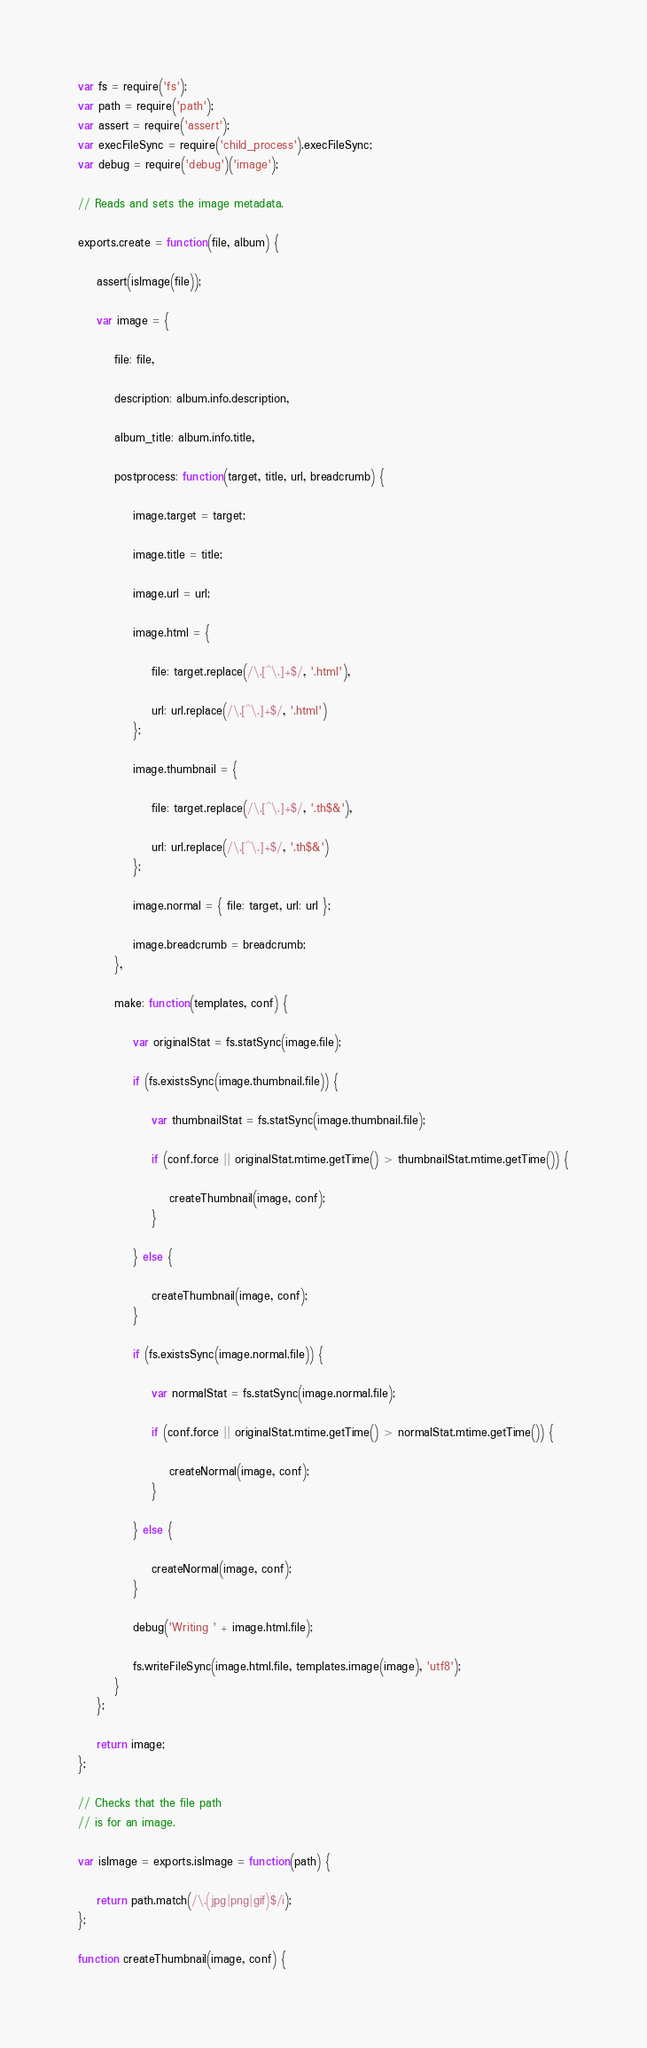Convert code to text. <code><loc_0><loc_0><loc_500><loc_500><_JavaScript_>var fs = require('fs');
var path = require('path');
var assert = require('assert');
var execFileSync = require('child_process').execFileSync;
var debug = require('debug')('image');

// Reads and sets the image metadata.

exports.create = function(file, album) {

    assert(isImage(file));

    var image = {

        file: file,

        description: album.info.description,

        album_title: album.info.title,

        postprocess: function(target, title, url, breadcrumb) {

            image.target = target;

            image.title = title;

            image.url = url;

            image.html = {

                file: target.replace(/\.[^\.]+$/, '.html'),

                url: url.replace(/\.[^\.]+$/, '.html')
            };

            image.thumbnail = {

                file: target.replace(/\.[^\.]+$/, '.th$&'),

                url: url.replace(/\.[^\.]+$/, '.th$&')
            };

            image.normal = { file: target, url: url };

            image.breadcrumb = breadcrumb;
        },

        make: function(templates, conf) {

            var originalStat = fs.statSync(image.file);

            if (fs.existsSync(image.thumbnail.file)) {

                var thumbnailStat = fs.statSync(image.thumbnail.file);

                if (conf.force || originalStat.mtime.getTime() > thumbnailStat.mtime.getTime()) {

                    createThumbnail(image, conf);
                }

            } else {

                createThumbnail(image, conf);
            }

            if (fs.existsSync(image.normal.file)) {

                var normalStat = fs.statSync(image.normal.file);

                if (conf.force || originalStat.mtime.getTime() > normalStat.mtime.getTime()) {

                    createNormal(image, conf);
                }

            } else {

                createNormal(image, conf);
            }

            debug('Writing ' + image.html.file);

            fs.writeFileSync(image.html.file, templates.image(image), 'utf8');
        }
    };

    return image;
};

// Checks that the file path
// is for an image.

var isImage = exports.isImage = function(path) {

    return path.match(/\.(jpg|png|gif)$/i);
};

function createThumbnail(image, conf) {
</code> 